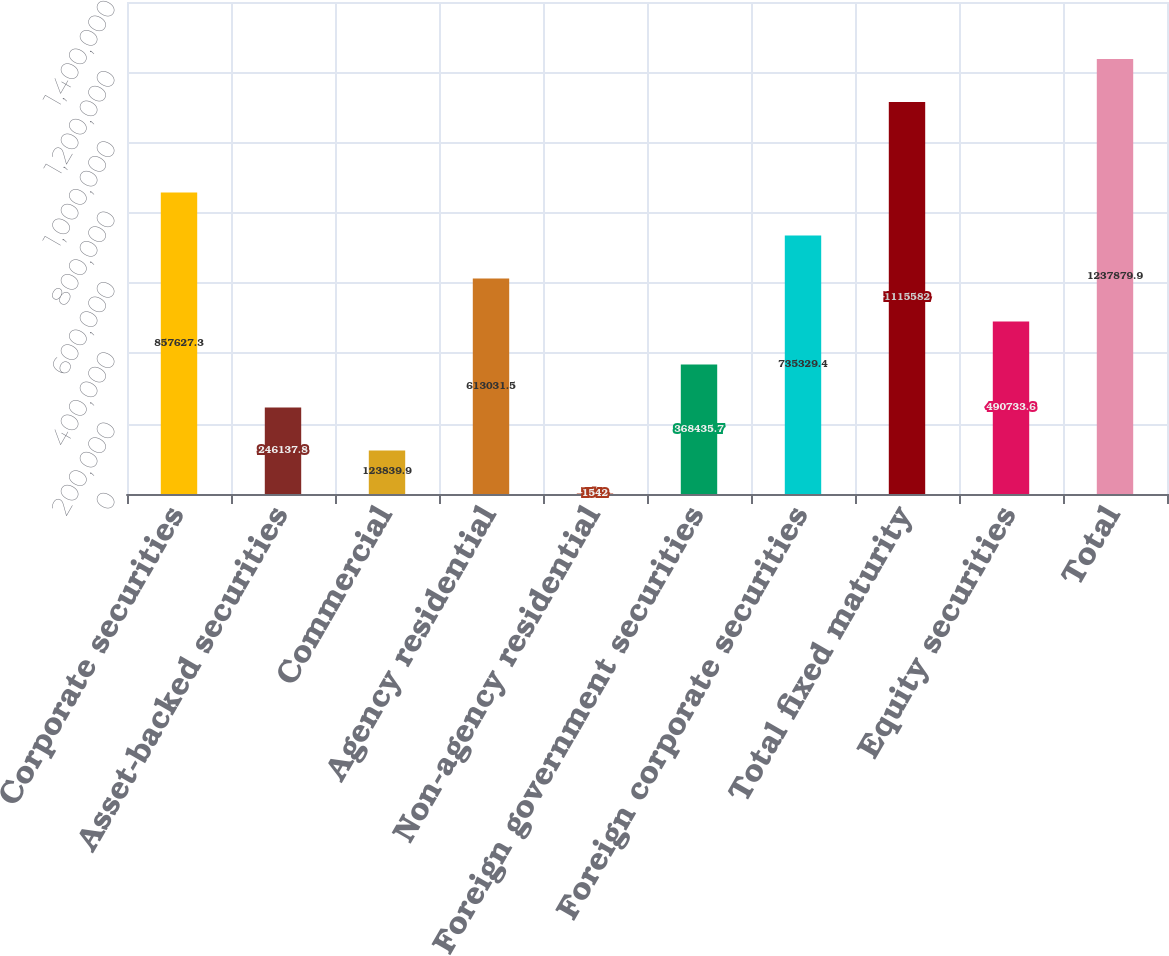<chart> <loc_0><loc_0><loc_500><loc_500><bar_chart><fcel>Corporate securities<fcel>Asset-backed securities<fcel>Commercial<fcel>Agency residential<fcel>Non-agency residential<fcel>Foreign government securities<fcel>Foreign corporate securities<fcel>Total fixed maturity<fcel>Equity securities<fcel>Total<nl><fcel>857627<fcel>246138<fcel>123840<fcel>613032<fcel>1542<fcel>368436<fcel>735329<fcel>1.11558e+06<fcel>490734<fcel>1.23788e+06<nl></chart> 